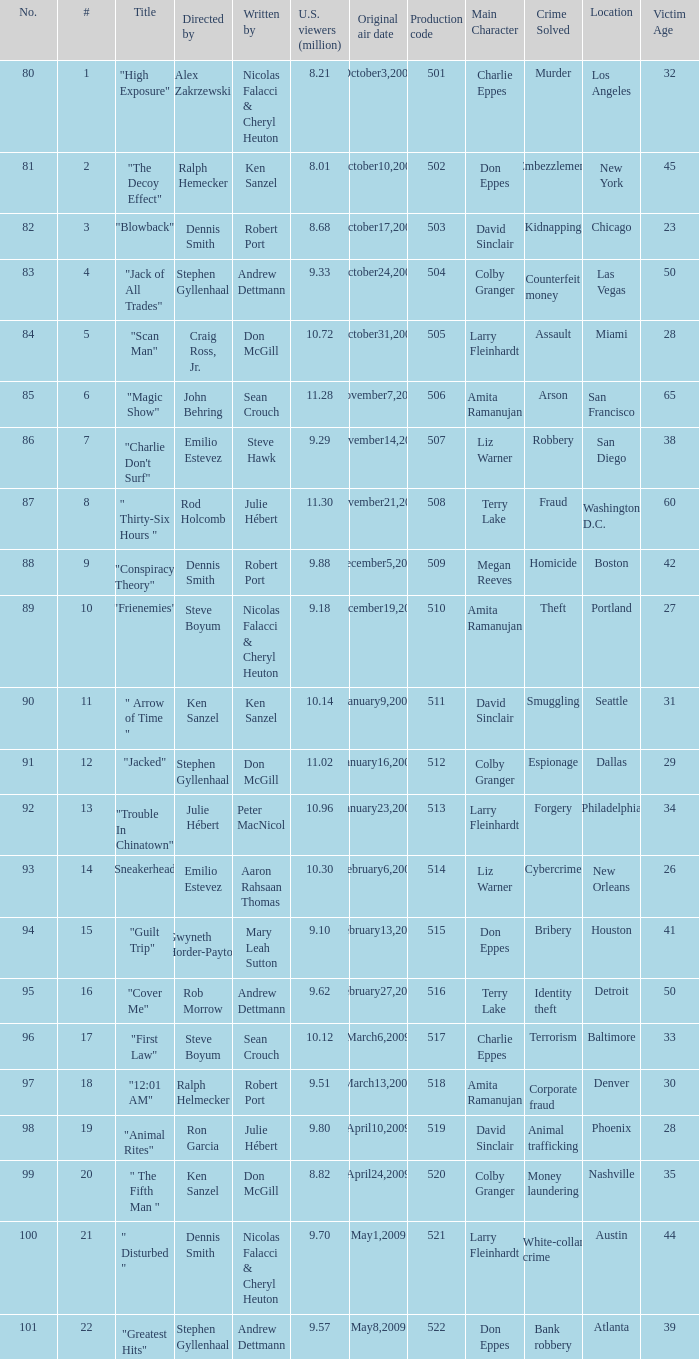What is the production code for the episode that had 9.18 million viewers (U.S.)? 510.0. 